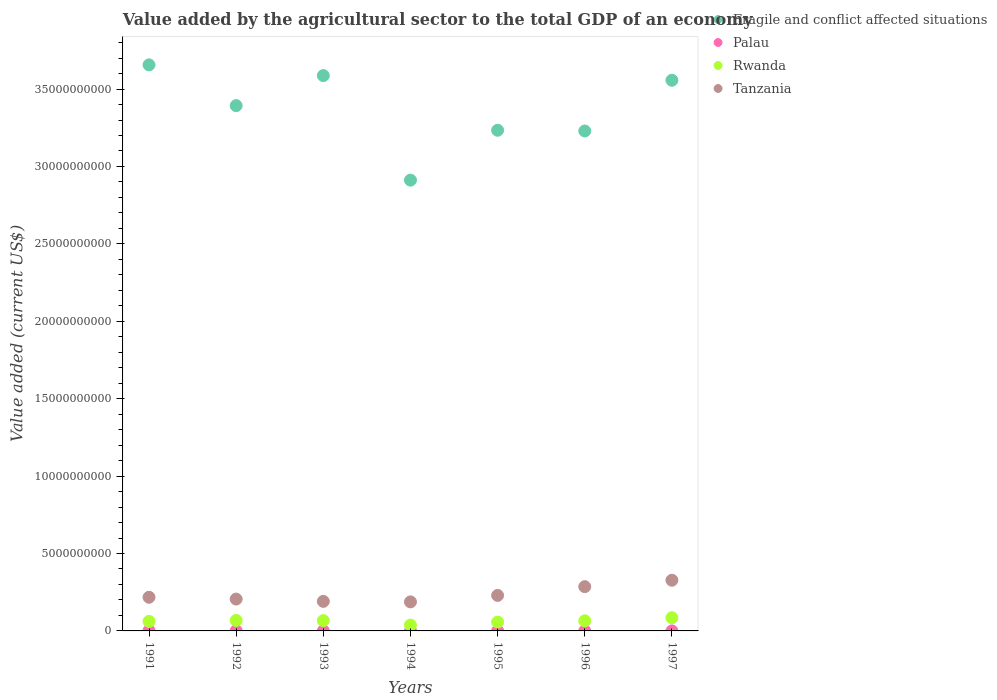How many different coloured dotlines are there?
Your response must be concise. 4. Is the number of dotlines equal to the number of legend labels?
Your response must be concise. Yes. What is the value added by the agricultural sector to the total GDP in Rwanda in 1997?
Provide a short and direct response. 8.51e+08. Across all years, what is the maximum value added by the agricultural sector to the total GDP in Palau?
Keep it short and to the point. 2.36e+07. Across all years, what is the minimum value added by the agricultural sector to the total GDP in Tanzania?
Give a very brief answer. 1.88e+09. In which year was the value added by the agricultural sector to the total GDP in Fragile and conflict affected situations maximum?
Ensure brevity in your answer.  1991. In which year was the value added by the agricultural sector to the total GDP in Rwanda minimum?
Make the answer very short. 1994. What is the total value added by the agricultural sector to the total GDP in Tanzania in the graph?
Provide a short and direct response. 1.64e+1. What is the difference between the value added by the agricultural sector to the total GDP in Rwanda in 1993 and that in 1995?
Give a very brief answer. 9.59e+07. What is the difference between the value added by the agricultural sector to the total GDP in Palau in 1991 and the value added by the agricultural sector to the total GDP in Rwanda in 1995?
Provide a short and direct response. -5.46e+08. What is the average value added by the agricultural sector to the total GDP in Fragile and conflict affected situations per year?
Your answer should be compact. 3.37e+1. In the year 1992, what is the difference between the value added by the agricultural sector to the total GDP in Palau and value added by the agricultural sector to the total GDP in Rwanda?
Your answer should be compact. -6.59e+08. In how many years, is the value added by the agricultural sector to the total GDP in Palau greater than 18000000000 US$?
Your answer should be compact. 0. What is the ratio of the value added by the agricultural sector to the total GDP in Tanzania in 1994 to that in 1997?
Give a very brief answer. 0.57. Is the value added by the agricultural sector to the total GDP in Tanzania in 1991 less than that in 1994?
Give a very brief answer. No. Is the difference between the value added by the agricultural sector to the total GDP in Palau in 1991 and 1997 greater than the difference between the value added by the agricultural sector to the total GDP in Rwanda in 1991 and 1997?
Your answer should be compact. Yes. What is the difference between the highest and the second highest value added by the agricultural sector to the total GDP in Fragile and conflict affected situations?
Ensure brevity in your answer.  6.92e+08. What is the difference between the highest and the lowest value added by the agricultural sector to the total GDP in Palau?
Provide a short and direct response. 2.02e+07. Is the sum of the value added by the agricultural sector to the total GDP in Fragile and conflict affected situations in 1991 and 1995 greater than the maximum value added by the agricultural sector to the total GDP in Palau across all years?
Your answer should be very brief. Yes. Is it the case that in every year, the sum of the value added by the agricultural sector to the total GDP in Fragile and conflict affected situations and value added by the agricultural sector to the total GDP in Tanzania  is greater than the sum of value added by the agricultural sector to the total GDP in Rwanda and value added by the agricultural sector to the total GDP in Palau?
Your answer should be very brief. Yes. How many dotlines are there?
Your answer should be compact. 4. How many years are there in the graph?
Your answer should be very brief. 7. Are the values on the major ticks of Y-axis written in scientific E-notation?
Provide a short and direct response. No. Does the graph contain grids?
Your answer should be compact. No. Where does the legend appear in the graph?
Your answer should be very brief. Top right. How many legend labels are there?
Your response must be concise. 4. What is the title of the graph?
Give a very brief answer. Value added by the agricultural sector to the total GDP of an economy. What is the label or title of the Y-axis?
Your answer should be very brief. Value added (current US$). What is the Value added (current US$) in Fragile and conflict affected situations in 1991?
Your response must be concise. 3.66e+1. What is the Value added (current US$) in Palau in 1991?
Keep it short and to the point. 2.36e+07. What is the Value added (current US$) in Rwanda in 1991?
Your response must be concise. 6.14e+08. What is the Value added (current US$) in Tanzania in 1991?
Ensure brevity in your answer.  2.17e+09. What is the Value added (current US$) in Fragile and conflict affected situations in 1992?
Offer a very short reply. 3.39e+1. What is the Value added (current US$) of Palau in 1992?
Your response must be concise. 1.53e+07. What is the Value added (current US$) in Rwanda in 1992?
Make the answer very short. 6.74e+08. What is the Value added (current US$) in Tanzania in 1992?
Offer a very short reply. 2.06e+09. What is the Value added (current US$) in Fragile and conflict affected situations in 1993?
Ensure brevity in your answer.  3.59e+1. What is the Value added (current US$) of Palau in 1993?
Offer a terse response. 8.08e+06. What is the Value added (current US$) in Rwanda in 1993?
Your response must be concise. 6.65e+08. What is the Value added (current US$) of Tanzania in 1993?
Your response must be concise. 1.91e+09. What is the Value added (current US$) of Fragile and conflict affected situations in 1994?
Provide a short and direct response. 2.91e+1. What is the Value added (current US$) of Palau in 1994?
Make the answer very short. 6.79e+06. What is the Value added (current US$) in Rwanda in 1994?
Give a very brief answer. 3.75e+08. What is the Value added (current US$) of Tanzania in 1994?
Offer a terse response. 1.88e+09. What is the Value added (current US$) of Fragile and conflict affected situations in 1995?
Make the answer very short. 3.23e+1. What is the Value added (current US$) of Palau in 1995?
Keep it short and to the point. 5.50e+06. What is the Value added (current US$) in Rwanda in 1995?
Your answer should be compact. 5.69e+08. What is the Value added (current US$) of Tanzania in 1995?
Offer a terse response. 2.29e+09. What is the Value added (current US$) of Fragile and conflict affected situations in 1996?
Provide a short and direct response. 3.23e+1. What is the Value added (current US$) in Palau in 1996?
Make the answer very short. 4.20e+06. What is the Value added (current US$) of Rwanda in 1996?
Your response must be concise. 6.52e+08. What is the Value added (current US$) of Tanzania in 1996?
Provide a short and direct response. 2.86e+09. What is the Value added (current US$) in Fragile and conflict affected situations in 1997?
Your response must be concise. 3.56e+1. What is the Value added (current US$) of Palau in 1997?
Give a very brief answer. 3.37e+06. What is the Value added (current US$) in Rwanda in 1997?
Offer a terse response. 8.51e+08. What is the Value added (current US$) of Tanzania in 1997?
Provide a short and direct response. 3.27e+09. Across all years, what is the maximum Value added (current US$) in Fragile and conflict affected situations?
Give a very brief answer. 3.66e+1. Across all years, what is the maximum Value added (current US$) of Palau?
Your answer should be compact. 2.36e+07. Across all years, what is the maximum Value added (current US$) in Rwanda?
Give a very brief answer. 8.51e+08. Across all years, what is the maximum Value added (current US$) of Tanzania?
Ensure brevity in your answer.  3.27e+09. Across all years, what is the minimum Value added (current US$) of Fragile and conflict affected situations?
Offer a terse response. 2.91e+1. Across all years, what is the minimum Value added (current US$) in Palau?
Provide a short and direct response. 3.37e+06. Across all years, what is the minimum Value added (current US$) of Rwanda?
Offer a very short reply. 3.75e+08. Across all years, what is the minimum Value added (current US$) of Tanzania?
Ensure brevity in your answer.  1.88e+09. What is the total Value added (current US$) in Fragile and conflict affected situations in the graph?
Your response must be concise. 2.36e+11. What is the total Value added (current US$) in Palau in the graph?
Provide a succinct answer. 6.68e+07. What is the total Value added (current US$) in Rwanda in the graph?
Keep it short and to the point. 4.40e+09. What is the total Value added (current US$) of Tanzania in the graph?
Ensure brevity in your answer.  1.64e+1. What is the difference between the Value added (current US$) of Fragile and conflict affected situations in 1991 and that in 1992?
Provide a succinct answer. 2.63e+09. What is the difference between the Value added (current US$) in Palau in 1991 and that in 1992?
Offer a very short reply. 8.32e+06. What is the difference between the Value added (current US$) of Rwanda in 1991 and that in 1992?
Your response must be concise. -6.02e+07. What is the difference between the Value added (current US$) in Tanzania in 1991 and that in 1992?
Offer a terse response. 1.17e+08. What is the difference between the Value added (current US$) in Fragile and conflict affected situations in 1991 and that in 1993?
Provide a succinct answer. 6.92e+08. What is the difference between the Value added (current US$) of Palau in 1991 and that in 1993?
Provide a short and direct response. 1.55e+07. What is the difference between the Value added (current US$) in Rwanda in 1991 and that in 1993?
Your answer should be compact. -5.08e+07. What is the difference between the Value added (current US$) of Tanzania in 1991 and that in 1993?
Provide a short and direct response. 2.65e+08. What is the difference between the Value added (current US$) of Fragile and conflict affected situations in 1991 and that in 1994?
Make the answer very short. 7.45e+09. What is the difference between the Value added (current US$) in Palau in 1991 and that in 1994?
Make the answer very short. 1.68e+07. What is the difference between the Value added (current US$) in Rwanda in 1991 and that in 1994?
Keep it short and to the point. 2.39e+08. What is the difference between the Value added (current US$) of Tanzania in 1991 and that in 1994?
Ensure brevity in your answer.  2.98e+08. What is the difference between the Value added (current US$) of Fragile and conflict affected situations in 1991 and that in 1995?
Make the answer very short. 4.22e+09. What is the difference between the Value added (current US$) in Palau in 1991 and that in 1995?
Ensure brevity in your answer.  1.81e+07. What is the difference between the Value added (current US$) of Rwanda in 1991 and that in 1995?
Your answer should be very brief. 4.51e+07. What is the difference between the Value added (current US$) in Tanzania in 1991 and that in 1995?
Provide a succinct answer. -1.20e+08. What is the difference between the Value added (current US$) of Fragile and conflict affected situations in 1991 and that in 1996?
Offer a very short reply. 4.27e+09. What is the difference between the Value added (current US$) of Palau in 1991 and that in 1996?
Your answer should be very brief. 1.94e+07. What is the difference between the Value added (current US$) of Rwanda in 1991 and that in 1996?
Provide a succinct answer. -3.81e+07. What is the difference between the Value added (current US$) in Tanzania in 1991 and that in 1996?
Make the answer very short. -6.85e+08. What is the difference between the Value added (current US$) of Fragile and conflict affected situations in 1991 and that in 1997?
Make the answer very short. 9.93e+08. What is the difference between the Value added (current US$) of Palau in 1991 and that in 1997?
Offer a terse response. 2.02e+07. What is the difference between the Value added (current US$) in Rwanda in 1991 and that in 1997?
Your answer should be very brief. -2.37e+08. What is the difference between the Value added (current US$) of Tanzania in 1991 and that in 1997?
Provide a short and direct response. -1.10e+09. What is the difference between the Value added (current US$) in Fragile and conflict affected situations in 1992 and that in 1993?
Make the answer very short. -1.94e+09. What is the difference between the Value added (current US$) in Palau in 1992 and that in 1993?
Provide a short and direct response. 7.19e+06. What is the difference between the Value added (current US$) in Rwanda in 1992 and that in 1993?
Your answer should be compact. 9.31e+06. What is the difference between the Value added (current US$) of Tanzania in 1992 and that in 1993?
Give a very brief answer. 1.49e+08. What is the difference between the Value added (current US$) in Fragile and conflict affected situations in 1992 and that in 1994?
Offer a very short reply. 4.81e+09. What is the difference between the Value added (current US$) of Palau in 1992 and that in 1994?
Keep it short and to the point. 8.48e+06. What is the difference between the Value added (current US$) in Rwanda in 1992 and that in 1994?
Keep it short and to the point. 2.99e+08. What is the difference between the Value added (current US$) of Tanzania in 1992 and that in 1994?
Make the answer very short. 1.81e+08. What is the difference between the Value added (current US$) of Fragile and conflict affected situations in 1992 and that in 1995?
Keep it short and to the point. 1.59e+09. What is the difference between the Value added (current US$) of Palau in 1992 and that in 1995?
Provide a short and direct response. 9.78e+06. What is the difference between the Value added (current US$) of Rwanda in 1992 and that in 1995?
Give a very brief answer. 1.05e+08. What is the difference between the Value added (current US$) in Tanzania in 1992 and that in 1995?
Provide a short and direct response. -2.37e+08. What is the difference between the Value added (current US$) of Fragile and conflict affected situations in 1992 and that in 1996?
Offer a very short reply. 1.64e+09. What is the difference between the Value added (current US$) of Palau in 1992 and that in 1996?
Provide a succinct answer. 1.11e+07. What is the difference between the Value added (current US$) in Rwanda in 1992 and that in 1996?
Ensure brevity in your answer.  2.21e+07. What is the difference between the Value added (current US$) of Tanzania in 1992 and that in 1996?
Provide a short and direct response. -8.02e+08. What is the difference between the Value added (current US$) of Fragile and conflict affected situations in 1992 and that in 1997?
Provide a short and direct response. -1.64e+09. What is the difference between the Value added (current US$) in Palau in 1992 and that in 1997?
Keep it short and to the point. 1.19e+07. What is the difference between the Value added (current US$) in Rwanda in 1992 and that in 1997?
Offer a very short reply. -1.77e+08. What is the difference between the Value added (current US$) in Tanzania in 1992 and that in 1997?
Ensure brevity in your answer.  -1.22e+09. What is the difference between the Value added (current US$) in Fragile and conflict affected situations in 1993 and that in 1994?
Keep it short and to the point. 6.75e+09. What is the difference between the Value added (current US$) of Palau in 1993 and that in 1994?
Your answer should be compact. 1.29e+06. What is the difference between the Value added (current US$) in Rwanda in 1993 and that in 1994?
Give a very brief answer. 2.90e+08. What is the difference between the Value added (current US$) of Tanzania in 1993 and that in 1994?
Provide a succinct answer. 3.27e+07. What is the difference between the Value added (current US$) in Fragile and conflict affected situations in 1993 and that in 1995?
Keep it short and to the point. 3.53e+09. What is the difference between the Value added (current US$) in Palau in 1993 and that in 1995?
Give a very brief answer. 2.58e+06. What is the difference between the Value added (current US$) in Rwanda in 1993 and that in 1995?
Your answer should be very brief. 9.59e+07. What is the difference between the Value added (current US$) in Tanzania in 1993 and that in 1995?
Ensure brevity in your answer.  -3.85e+08. What is the difference between the Value added (current US$) in Fragile and conflict affected situations in 1993 and that in 1996?
Your answer should be very brief. 3.58e+09. What is the difference between the Value added (current US$) in Palau in 1993 and that in 1996?
Make the answer very short. 3.88e+06. What is the difference between the Value added (current US$) in Rwanda in 1993 and that in 1996?
Your response must be concise. 1.28e+07. What is the difference between the Value added (current US$) in Tanzania in 1993 and that in 1996?
Offer a terse response. -9.51e+08. What is the difference between the Value added (current US$) in Fragile and conflict affected situations in 1993 and that in 1997?
Your answer should be very brief. 3.01e+08. What is the difference between the Value added (current US$) in Palau in 1993 and that in 1997?
Keep it short and to the point. 4.71e+06. What is the difference between the Value added (current US$) of Rwanda in 1993 and that in 1997?
Provide a succinct answer. -1.86e+08. What is the difference between the Value added (current US$) of Tanzania in 1993 and that in 1997?
Provide a succinct answer. -1.36e+09. What is the difference between the Value added (current US$) in Fragile and conflict affected situations in 1994 and that in 1995?
Provide a succinct answer. -3.22e+09. What is the difference between the Value added (current US$) in Palau in 1994 and that in 1995?
Offer a very short reply. 1.29e+06. What is the difference between the Value added (current US$) in Rwanda in 1994 and that in 1995?
Your answer should be very brief. -1.94e+08. What is the difference between the Value added (current US$) in Tanzania in 1994 and that in 1995?
Offer a very short reply. -4.18e+08. What is the difference between the Value added (current US$) in Fragile and conflict affected situations in 1994 and that in 1996?
Your answer should be very brief. -3.18e+09. What is the difference between the Value added (current US$) of Palau in 1994 and that in 1996?
Give a very brief answer. 2.59e+06. What is the difference between the Value added (current US$) in Rwanda in 1994 and that in 1996?
Your answer should be very brief. -2.77e+08. What is the difference between the Value added (current US$) of Tanzania in 1994 and that in 1996?
Provide a succinct answer. -9.83e+08. What is the difference between the Value added (current US$) of Fragile and conflict affected situations in 1994 and that in 1997?
Provide a short and direct response. -6.45e+09. What is the difference between the Value added (current US$) in Palau in 1994 and that in 1997?
Your response must be concise. 3.42e+06. What is the difference between the Value added (current US$) in Rwanda in 1994 and that in 1997?
Give a very brief answer. -4.76e+08. What is the difference between the Value added (current US$) of Tanzania in 1994 and that in 1997?
Offer a terse response. -1.40e+09. What is the difference between the Value added (current US$) in Fragile and conflict affected situations in 1995 and that in 1996?
Offer a very short reply. 4.73e+07. What is the difference between the Value added (current US$) of Palau in 1995 and that in 1996?
Ensure brevity in your answer.  1.29e+06. What is the difference between the Value added (current US$) in Rwanda in 1995 and that in 1996?
Make the answer very short. -8.32e+07. What is the difference between the Value added (current US$) of Tanzania in 1995 and that in 1996?
Your answer should be compact. -5.65e+08. What is the difference between the Value added (current US$) of Fragile and conflict affected situations in 1995 and that in 1997?
Provide a succinct answer. -3.23e+09. What is the difference between the Value added (current US$) of Palau in 1995 and that in 1997?
Provide a short and direct response. 2.13e+06. What is the difference between the Value added (current US$) in Rwanda in 1995 and that in 1997?
Give a very brief answer. -2.82e+08. What is the difference between the Value added (current US$) of Tanzania in 1995 and that in 1997?
Provide a succinct answer. -9.80e+08. What is the difference between the Value added (current US$) in Fragile and conflict affected situations in 1996 and that in 1997?
Provide a succinct answer. -3.28e+09. What is the difference between the Value added (current US$) in Palau in 1996 and that in 1997?
Keep it short and to the point. 8.35e+05. What is the difference between the Value added (current US$) of Rwanda in 1996 and that in 1997?
Offer a terse response. -1.99e+08. What is the difference between the Value added (current US$) in Tanzania in 1996 and that in 1997?
Keep it short and to the point. -4.14e+08. What is the difference between the Value added (current US$) in Fragile and conflict affected situations in 1991 and the Value added (current US$) in Palau in 1992?
Offer a terse response. 3.65e+1. What is the difference between the Value added (current US$) in Fragile and conflict affected situations in 1991 and the Value added (current US$) in Rwanda in 1992?
Provide a short and direct response. 3.59e+1. What is the difference between the Value added (current US$) of Fragile and conflict affected situations in 1991 and the Value added (current US$) of Tanzania in 1992?
Provide a succinct answer. 3.45e+1. What is the difference between the Value added (current US$) in Palau in 1991 and the Value added (current US$) in Rwanda in 1992?
Make the answer very short. -6.51e+08. What is the difference between the Value added (current US$) in Palau in 1991 and the Value added (current US$) in Tanzania in 1992?
Offer a very short reply. -2.03e+09. What is the difference between the Value added (current US$) in Rwanda in 1991 and the Value added (current US$) in Tanzania in 1992?
Offer a very short reply. -1.44e+09. What is the difference between the Value added (current US$) in Fragile and conflict affected situations in 1991 and the Value added (current US$) in Palau in 1993?
Ensure brevity in your answer.  3.66e+1. What is the difference between the Value added (current US$) of Fragile and conflict affected situations in 1991 and the Value added (current US$) of Rwanda in 1993?
Offer a very short reply. 3.59e+1. What is the difference between the Value added (current US$) of Fragile and conflict affected situations in 1991 and the Value added (current US$) of Tanzania in 1993?
Your answer should be compact. 3.47e+1. What is the difference between the Value added (current US$) in Palau in 1991 and the Value added (current US$) in Rwanda in 1993?
Your answer should be very brief. -6.42e+08. What is the difference between the Value added (current US$) of Palau in 1991 and the Value added (current US$) of Tanzania in 1993?
Provide a succinct answer. -1.88e+09. What is the difference between the Value added (current US$) in Rwanda in 1991 and the Value added (current US$) in Tanzania in 1993?
Make the answer very short. -1.29e+09. What is the difference between the Value added (current US$) in Fragile and conflict affected situations in 1991 and the Value added (current US$) in Palau in 1994?
Offer a very short reply. 3.66e+1. What is the difference between the Value added (current US$) of Fragile and conflict affected situations in 1991 and the Value added (current US$) of Rwanda in 1994?
Give a very brief answer. 3.62e+1. What is the difference between the Value added (current US$) of Fragile and conflict affected situations in 1991 and the Value added (current US$) of Tanzania in 1994?
Provide a short and direct response. 3.47e+1. What is the difference between the Value added (current US$) in Palau in 1991 and the Value added (current US$) in Rwanda in 1994?
Give a very brief answer. -3.51e+08. What is the difference between the Value added (current US$) in Palau in 1991 and the Value added (current US$) in Tanzania in 1994?
Give a very brief answer. -1.85e+09. What is the difference between the Value added (current US$) of Rwanda in 1991 and the Value added (current US$) of Tanzania in 1994?
Offer a terse response. -1.26e+09. What is the difference between the Value added (current US$) of Fragile and conflict affected situations in 1991 and the Value added (current US$) of Palau in 1995?
Your response must be concise. 3.66e+1. What is the difference between the Value added (current US$) in Fragile and conflict affected situations in 1991 and the Value added (current US$) in Rwanda in 1995?
Provide a succinct answer. 3.60e+1. What is the difference between the Value added (current US$) of Fragile and conflict affected situations in 1991 and the Value added (current US$) of Tanzania in 1995?
Keep it short and to the point. 3.43e+1. What is the difference between the Value added (current US$) in Palau in 1991 and the Value added (current US$) in Rwanda in 1995?
Ensure brevity in your answer.  -5.46e+08. What is the difference between the Value added (current US$) of Palau in 1991 and the Value added (current US$) of Tanzania in 1995?
Your answer should be very brief. -2.27e+09. What is the difference between the Value added (current US$) of Rwanda in 1991 and the Value added (current US$) of Tanzania in 1995?
Provide a short and direct response. -1.68e+09. What is the difference between the Value added (current US$) of Fragile and conflict affected situations in 1991 and the Value added (current US$) of Palau in 1996?
Your answer should be very brief. 3.66e+1. What is the difference between the Value added (current US$) in Fragile and conflict affected situations in 1991 and the Value added (current US$) in Rwanda in 1996?
Your answer should be very brief. 3.59e+1. What is the difference between the Value added (current US$) in Fragile and conflict affected situations in 1991 and the Value added (current US$) in Tanzania in 1996?
Offer a terse response. 3.37e+1. What is the difference between the Value added (current US$) of Palau in 1991 and the Value added (current US$) of Rwanda in 1996?
Offer a terse response. -6.29e+08. What is the difference between the Value added (current US$) in Palau in 1991 and the Value added (current US$) in Tanzania in 1996?
Ensure brevity in your answer.  -2.84e+09. What is the difference between the Value added (current US$) of Rwanda in 1991 and the Value added (current US$) of Tanzania in 1996?
Give a very brief answer. -2.24e+09. What is the difference between the Value added (current US$) of Fragile and conflict affected situations in 1991 and the Value added (current US$) of Palau in 1997?
Keep it short and to the point. 3.66e+1. What is the difference between the Value added (current US$) in Fragile and conflict affected situations in 1991 and the Value added (current US$) in Rwanda in 1997?
Make the answer very short. 3.57e+1. What is the difference between the Value added (current US$) of Fragile and conflict affected situations in 1991 and the Value added (current US$) of Tanzania in 1997?
Provide a succinct answer. 3.33e+1. What is the difference between the Value added (current US$) of Palau in 1991 and the Value added (current US$) of Rwanda in 1997?
Offer a terse response. -8.27e+08. What is the difference between the Value added (current US$) of Palau in 1991 and the Value added (current US$) of Tanzania in 1997?
Offer a terse response. -3.25e+09. What is the difference between the Value added (current US$) in Rwanda in 1991 and the Value added (current US$) in Tanzania in 1997?
Your answer should be very brief. -2.66e+09. What is the difference between the Value added (current US$) of Fragile and conflict affected situations in 1992 and the Value added (current US$) of Palau in 1993?
Give a very brief answer. 3.39e+1. What is the difference between the Value added (current US$) in Fragile and conflict affected situations in 1992 and the Value added (current US$) in Rwanda in 1993?
Offer a terse response. 3.33e+1. What is the difference between the Value added (current US$) of Fragile and conflict affected situations in 1992 and the Value added (current US$) of Tanzania in 1993?
Your answer should be very brief. 3.20e+1. What is the difference between the Value added (current US$) in Palau in 1992 and the Value added (current US$) in Rwanda in 1993?
Give a very brief answer. -6.50e+08. What is the difference between the Value added (current US$) of Palau in 1992 and the Value added (current US$) of Tanzania in 1993?
Your answer should be compact. -1.89e+09. What is the difference between the Value added (current US$) of Rwanda in 1992 and the Value added (current US$) of Tanzania in 1993?
Your answer should be very brief. -1.23e+09. What is the difference between the Value added (current US$) in Fragile and conflict affected situations in 1992 and the Value added (current US$) in Palau in 1994?
Offer a very short reply. 3.39e+1. What is the difference between the Value added (current US$) of Fragile and conflict affected situations in 1992 and the Value added (current US$) of Rwanda in 1994?
Your answer should be compact. 3.36e+1. What is the difference between the Value added (current US$) in Fragile and conflict affected situations in 1992 and the Value added (current US$) in Tanzania in 1994?
Your answer should be compact. 3.21e+1. What is the difference between the Value added (current US$) in Palau in 1992 and the Value added (current US$) in Rwanda in 1994?
Your answer should be compact. -3.60e+08. What is the difference between the Value added (current US$) in Palau in 1992 and the Value added (current US$) in Tanzania in 1994?
Your response must be concise. -1.86e+09. What is the difference between the Value added (current US$) of Rwanda in 1992 and the Value added (current US$) of Tanzania in 1994?
Your answer should be compact. -1.20e+09. What is the difference between the Value added (current US$) of Fragile and conflict affected situations in 1992 and the Value added (current US$) of Palau in 1995?
Your response must be concise. 3.39e+1. What is the difference between the Value added (current US$) of Fragile and conflict affected situations in 1992 and the Value added (current US$) of Rwanda in 1995?
Your response must be concise. 3.34e+1. What is the difference between the Value added (current US$) in Fragile and conflict affected situations in 1992 and the Value added (current US$) in Tanzania in 1995?
Provide a short and direct response. 3.16e+1. What is the difference between the Value added (current US$) of Palau in 1992 and the Value added (current US$) of Rwanda in 1995?
Your answer should be very brief. -5.54e+08. What is the difference between the Value added (current US$) of Palau in 1992 and the Value added (current US$) of Tanzania in 1995?
Your response must be concise. -2.28e+09. What is the difference between the Value added (current US$) of Rwanda in 1992 and the Value added (current US$) of Tanzania in 1995?
Ensure brevity in your answer.  -1.62e+09. What is the difference between the Value added (current US$) of Fragile and conflict affected situations in 1992 and the Value added (current US$) of Palau in 1996?
Offer a very short reply. 3.39e+1. What is the difference between the Value added (current US$) in Fragile and conflict affected situations in 1992 and the Value added (current US$) in Rwanda in 1996?
Keep it short and to the point. 3.33e+1. What is the difference between the Value added (current US$) of Fragile and conflict affected situations in 1992 and the Value added (current US$) of Tanzania in 1996?
Give a very brief answer. 3.11e+1. What is the difference between the Value added (current US$) of Palau in 1992 and the Value added (current US$) of Rwanda in 1996?
Your answer should be compact. -6.37e+08. What is the difference between the Value added (current US$) of Palau in 1992 and the Value added (current US$) of Tanzania in 1996?
Offer a terse response. -2.84e+09. What is the difference between the Value added (current US$) of Rwanda in 1992 and the Value added (current US$) of Tanzania in 1996?
Your response must be concise. -2.18e+09. What is the difference between the Value added (current US$) of Fragile and conflict affected situations in 1992 and the Value added (current US$) of Palau in 1997?
Your response must be concise. 3.39e+1. What is the difference between the Value added (current US$) in Fragile and conflict affected situations in 1992 and the Value added (current US$) in Rwanda in 1997?
Make the answer very short. 3.31e+1. What is the difference between the Value added (current US$) of Fragile and conflict affected situations in 1992 and the Value added (current US$) of Tanzania in 1997?
Your response must be concise. 3.07e+1. What is the difference between the Value added (current US$) of Palau in 1992 and the Value added (current US$) of Rwanda in 1997?
Offer a very short reply. -8.36e+08. What is the difference between the Value added (current US$) in Palau in 1992 and the Value added (current US$) in Tanzania in 1997?
Your response must be concise. -3.26e+09. What is the difference between the Value added (current US$) of Rwanda in 1992 and the Value added (current US$) of Tanzania in 1997?
Offer a terse response. -2.60e+09. What is the difference between the Value added (current US$) in Fragile and conflict affected situations in 1993 and the Value added (current US$) in Palau in 1994?
Make the answer very short. 3.59e+1. What is the difference between the Value added (current US$) in Fragile and conflict affected situations in 1993 and the Value added (current US$) in Rwanda in 1994?
Provide a succinct answer. 3.55e+1. What is the difference between the Value added (current US$) in Fragile and conflict affected situations in 1993 and the Value added (current US$) in Tanzania in 1994?
Your response must be concise. 3.40e+1. What is the difference between the Value added (current US$) in Palau in 1993 and the Value added (current US$) in Rwanda in 1994?
Offer a very short reply. -3.67e+08. What is the difference between the Value added (current US$) of Palau in 1993 and the Value added (current US$) of Tanzania in 1994?
Provide a succinct answer. -1.87e+09. What is the difference between the Value added (current US$) in Rwanda in 1993 and the Value added (current US$) in Tanzania in 1994?
Keep it short and to the point. -1.21e+09. What is the difference between the Value added (current US$) of Fragile and conflict affected situations in 1993 and the Value added (current US$) of Palau in 1995?
Your answer should be very brief. 3.59e+1. What is the difference between the Value added (current US$) of Fragile and conflict affected situations in 1993 and the Value added (current US$) of Rwanda in 1995?
Your response must be concise. 3.53e+1. What is the difference between the Value added (current US$) of Fragile and conflict affected situations in 1993 and the Value added (current US$) of Tanzania in 1995?
Your answer should be very brief. 3.36e+1. What is the difference between the Value added (current US$) in Palau in 1993 and the Value added (current US$) in Rwanda in 1995?
Give a very brief answer. -5.61e+08. What is the difference between the Value added (current US$) of Palau in 1993 and the Value added (current US$) of Tanzania in 1995?
Provide a short and direct response. -2.29e+09. What is the difference between the Value added (current US$) in Rwanda in 1993 and the Value added (current US$) in Tanzania in 1995?
Offer a very short reply. -1.63e+09. What is the difference between the Value added (current US$) in Fragile and conflict affected situations in 1993 and the Value added (current US$) in Palau in 1996?
Keep it short and to the point. 3.59e+1. What is the difference between the Value added (current US$) of Fragile and conflict affected situations in 1993 and the Value added (current US$) of Rwanda in 1996?
Give a very brief answer. 3.52e+1. What is the difference between the Value added (current US$) of Fragile and conflict affected situations in 1993 and the Value added (current US$) of Tanzania in 1996?
Provide a short and direct response. 3.30e+1. What is the difference between the Value added (current US$) in Palau in 1993 and the Value added (current US$) in Rwanda in 1996?
Your answer should be very brief. -6.44e+08. What is the difference between the Value added (current US$) in Palau in 1993 and the Value added (current US$) in Tanzania in 1996?
Your answer should be very brief. -2.85e+09. What is the difference between the Value added (current US$) of Rwanda in 1993 and the Value added (current US$) of Tanzania in 1996?
Your answer should be very brief. -2.19e+09. What is the difference between the Value added (current US$) of Fragile and conflict affected situations in 1993 and the Value added (current US$) of Palau in 1997?
Keep it short and to the point. 3.59e+1. What is the difference between the Value added (current US$) of Fragile and conflict affected situations in 1993 and the Value added (current US$) of Rwanda in 1997?
Make the answer very short. 3.50e+1. What is the difference between the Value added (current US$) in Fragile and conflict affected situations in 1993 and the Value added (current US$) in Tanzania in 1997?
Give a very brief answer. 3.26e+1. What is the difference between the Value added (current US$) in Palau in 1993 and the Value added (current US$) in Rwanda in 1997?
Provide a short and direct response. -8.43e+08. What is the difference between the Value added (current US$) of Palau in 1993 and the Value added (current US$) of Tanzania in 1997?
Keep it short and to the point. -3.27e+09. What is the difference between the Value added (current US$) of Rwanda in 1993 and the Value added (current US$) of Tanzania in 1997?
Offer a terse response. -2.61e+09. What is the difference between the Value added (current US$) of Fragile and conflict affected situations in 1994 and the Value added (current US$) of Palau in 1995?
Offer a terse response. 2.91e+1. What is the difference between the Value added (current US$) of Fragile and conflict affected situations in 1994 and the Value added (current US$) of Rwanda in 1995?
Give a very brief answer. 2.85e+1. What is the difference between the Value added (current US$) of Fragile and conflict affected situations in 1994 and the Value added (current US$) of Tanzania in 1995?
Ensure brevity in your answer.  2.68e+1. What is the difference between the Value added (current US$) of Palau in 1994 and the Value added (current US$) of Rwanda in 1995?
Ensure brevity in your answer.  -5.62e+08. What is the difference between the Value added (current US$) in Palau in 1994 and the Value added (current US$) in Tanzania in 1995?
Offer a very short reply. -2.29e+09. What is the difference between the Value added (current US$) in Rwanda in 1994 and the Value added (current US$) in Tanzania in 1995?
Your response must be concise. -1.92e+09. What is the difference between the Value added (current US$) of Fragile and conflict affected situations in 1994 and the Value added (current US$) of Palau in 1996?
Offer a terse response. 2.91e+1. What is the difference between the Value added (current US$) in Fragile and conflict affected situations in 1994 and the Value added (current US$) in Rwanda in 1996?
Make the answer very short. 2.85e+1. What is the difference between the Value added (current US$) in Fragile and conflict affected situations in 1994 and the Value added (current US$) in Tanzania in 1996?
Your response must be concise. 2.63e+1. What is the difference between the Value added (current US$) of Palau in 1994 and the Value added (current US$) of Rwanda in 1996?
Give a very brief answer. -6.46e+08. What is the difference between the Value added (current US$) of Palau in 1994 and the Value added (current US$) of Tanzania in 1996?
Make the answer very short. -2.85e+09. What is the difference between the Value added (current US$) of Rwanda in 1994 and the Value added (current US$) of Tanzania in 1996?
Offer a terse response. -2.48e+09. What is the difference between the Value added (current US$) in Fragile and conflict affected situations in 1994 and the Value added (current US$) in Palau in 1997?
Offer a terse response. 2.91e+1. What is the difference between the Value added (current US$) of Fragile and conflict affected situations in 1994 and the Value added (current US$) of Rwanda in 1997?
Provide a short and direct response. 2.83e+1. What is the difference between the Value added (current US$) of Fragile and conflict affected situations in 1994 and the Value added (current US$) of Tanzania in 1997?
Your answer should be compact. 2.58e+1. What is the difference between the Value added (current US$) in Palau in 1994 and the Value added (current US$) in Rwanda in 1997?
Keep it short and to the point. -8.44e+08. What is the difference between the Value added (current US$) in Palau in 1994 and the Value added (current US$) in Tanzania in 1997?
Keep it short and to the point. -3.27e+09. What is the difference between the Value added (current US$) of Rwanda in 1994 and the Value added (current US$) of Tanzania in 1997?
Your response must be concise. -2.90e+09. What is the difference between the Value added (current US$) in Fragile and conflict affected situations in 1995 and the Value added (current US$) in Palau in 1996?
Ensure brevity in your answer.  3.23e+1. What is the difference between the Value added (current US$) of Fragile and conflict affected situations in 1995 and the Value added (current US$) of Rwanda in 1996?
Offer a very short reply. 3.17e+1. What is the difference between the Value added (current US$) of Fragile and conflict affected situations in 1995 and the Value added (current US$) of Tanzania in 1996?
Give a very brief answer. 2.95e+1. What is the difference between the Value added (current US$) of Palau in 1995 and the Value added (current US$) of Rwanda in 1996?
Offer a very short reply. -6.47e+08. What is the difference between the Value added (current US$) in Palau in 1995 and the Value added (current US$) in Tanzania in 1996?
Make the answer very short. -2.85e+09. What is the difference between the Value added (current US$) in Rwanda in 1995 and the Value added (current US$) in Tanzania in 1996?
Provide a succinct answer. -2.29e+09. What is the difference between the Value added (current US$) in Fragile and conflict affected situations in 1995 and the Value added (current US$) in Palau in 1997?
Your answer should be compact. 3.23e+1. What is the difference between the Value added (current US$) of Fragile and conflict affected situations in 1995 and the Value added (current US$) of Rwanda in 1997?
Offer a very short reply. 3.15e+1. What is the difference between the Value added (current US$) in Fragile and conflict affected situations in 1995 and the Value added (current US$) in Tanzania in 1997?
Your answer should be very brief. 2.91e+1. What is the difference between the Value added (current US$) of Palau in 1995 and the Value added (current US$) of Rwanda in 1997?
Give a very brief answer. -8.45e+08. What is the difference between the Value added (current US$) in Palau in 1995 and the Value added (current US$) in Tanzania in 1997?
Your answer should be very brief. -3.27e+09. What is the difference between the Value added (current US$) in Rwanda in 1995 and the Value added (current US$) in Tanzania in 1997?
Provide a succinct answer. -2.70e+09. What is the difference between the Value added (current US$) in Fragile and conflict affected situations in 1996 and the Value added (current US$) in Palau in 1997?
Ensure brevity in your answer.  3.23e+1. What is the difference between the Value added (current US$) of Fragile and conflict affected situations in 1996 and the Value added (current US$) of Rwanda in 1997?
Give a very brief answer. 3.14e+1. What is the difference between the Value added (current US$) in Fragile and conflict affected situations in 1996 and the Value added (current US$) in Tanzania in 1997?
Ensure brevity in your answer.  2.90e+1. What is the difference between the Value added (current US$) of Palau in 1996 and the Value added (current US$) of Rwanda in 1997?
Ensure brevity in your answer.  -8.47e+08. What is the difference between the Value added (current US$) in Palau in 1996 and the Value added (current US$) in Tanzania in 1997?
Give a very brief answer. -3.27e+09. What is the difference between the Value added (current US$) in Rwanda in 1996 and the Value added (current US$) in Tanzania in 1997?
Give a very brief answer. -2.62e+09. What is the average Value added (current US$) of Fragile and conflict affected situations per year?
Make the answer very short. 3.37e+1. What is the average Value added (current US$) of Palau per year?
Give a very brief answer. 9.54e+06. What is the average Value added (current US$) of Rwanda per year?
Ensure brevity in your answer.  6.29e+08. What is the average Value added (current US$) in Tanzania per year?
Provide a short and direct response. 2.35e+09. In the year 1991, what is the difference between the Value added (current US$) of Fragile and conflict affected situations and Value added (current US$) of Palau?
Keep it short and to the point. 3.65e+1. In the year 1991, what is the difference between the Value added (current US$) of Fragile and conflict affected situations and Value added (current US$) of Rwanda?
Make the answer very short. 3.59e+1. In the year 1991, what is the difference between the Value added (current US$) of Fragile and conflict affected situations and Value added (current US$) of Tanzania?
Ensure brevity in your answer.  3.44e+1. In the year 1991, what is the difference between the Value added (current US$) in Palau and Value added (current US$) in Rwanda?
Make the answer very short. -5.91e+08. In the year 1991, what is the difference between the Value added (current US$) in Palau and Value added (current US$) in Tanzania?
Keep it short and to the point. -2.15e+09. In the year 1991, what is the difference between the Value added (current US$) in Rwanda and Value added (current US$) in Tanzania?
Offer a terse response. -1.56e+09. In the year 1992, what is the difference between the Value added (current US$) of Fragile and conflict affected situations and Value added (current US$) of Palau?
Give a very brief answer. 3.39e+1. In the year 1992, what is the difference between the Value added (current US$) in Fragile and conflict affected situations and Value added (current US$) in Rwanda?
Your response must be concise. 3.33e+1. In the year 1992, what is the difference between the Value added (current US$) of Fragile and conflict affected situations and Value added (current US$) of Tanzania?
Make the answer very short. 3.19e+1. In the year 1992, what is the difference between the Value added (current US$) of Palau and Value added (current US$) of Rwanda?
Your response must be concise. -6.59e+08. In the year 1992, what is the difference between the Value added (current US$) in Palau and Value added (current US$) in Tanzania?
Your answer should be compact. -2.04e+09. In the year 1992, what is the difference between the Value added (current US$) in Rwanda and Value added (current US$) in Tanzania?
Keep it short and to the point. -1.38e+09. In the year 1993, what is the difference between the Value added (current US$) of Fragile and conflict affected situations and Value added (current US$) of Palau?
Your answer should be compact. 3.59e+1. In the year 1993, what is the difference between the Value added (current US$) of Fragile and conflict affected situations and Value added (current US$) of Rwanda?
Give a very brief answer. 3.52e+1. In the year 1993, what is the difference between the Value added (current US$) of Fragile and conflict affected situations and Value added (current US$) of Tanzania?
Offer a terse response. 3.40e+1. In the year 1993, what is the difference between the Value added (current US$) in Palau and Value added (current US$) in Rwanda?
Provide a succinct answer. -6.57e+08. In the year 1993, what is the difference between the Value added (current US$) in Palau and Value added (current US$) in Tanzania?
Your response must be concise. -1.90e+09. In the year 1993, what is the difference between the Value added (current US$) of Rwanda and Value added (current US$) of Tanzania?
Your response must be concise. -1.24e+09. In the year 1994, what is the difference between the Value added (current US$) of Fragile and conflict affected situations and Value added (current US$) of Palau?
Offer a very short reply. 2.91e+1. In the year 1994, what is the difference between the Value added (current US$) in Fragile and conflict affected situations and Value added (current US$) in Rwanda?
Your answer should be compact. 2.87e+1. In the year 1994, what is the difference between the Value added (current US$) of Fragile and conflict affected situations and Value added (current US$) of Tanzania?
Your response must be concise. 2.72e+1. In the year 1994, what is the difference between the Value added (current US$) in Palau and Value added (current US$) in Rwanda?
Keep it short and to the point. -3.68e+08. In the year 1994, what is the difference between the Value added (current US$) of Palau and Value added (current US$) of Tanzania?
Offer a terse response. -1.87e+09. In the year 1994, what is the difference between the Value added (current US$) in Rwanda and Value added (current US$) in Tanzania?
Your answer should be very brief. -1.50e+09. In the year 1995, what is the difference between the Value added (current US$) in Fragile and conflict affected situations and Value added (current US$) in Palau?
Your answer should be compact. 3.23e+1. In the year 1995, what is the difference between the Value added (current US$) in Fragile and conflict affected situations and Value added (current US$) in Rwanda?
Your answer should be compact. 3.18e+1. In the year 1995, what is the difference between the Value added (current US$) of Fragile and conflict affected situations and Value added (current US$) of Tanzania?
Give a very brief answer. 3.00e+1. In the year 1995, what is the difference between the Value added (current US$) in Palau and Value added (current US$) in Rwanda?
Offer a terse response. -5.64e+08. In the year 1995, what is the difference between the Value added (current US$) in Palau and Value added (current US$) in Tanzania?
Ensure brevity in your answer.  -2.29e+09. In the year 1995, what is the difference between the Value added (current US$) in Rwanda and Value added (current US$) in Tanzania?
Make the answer very short. -1.72e+09. In the year 1996, what is the difference between the Value added (current US$) in Fragile and conflict affected situations and Value added (current US$) in Palau?
Offer a terse response. 3.23e+1. In the year 1996, what is the difference between the Value added (current US$) of Fragile and conflict affected situations and Value added (current US$) of Rwanda?
Provide a succinct answer. 3.16e+1. In the year 1996, what is the difference between the Value added (current US$) in Fragile and conflict affected situations and Value added (current US$) in Tanzania?
Ensure brevity in your answer.  2.94e+1. In the year 1996, what is the difference between the Value added (current US$) of Palau and Value added (current US$) of Rwanda?
Provide a succinct answer. -6.48e+08. In the year 1996, what is the difference between the Value added (current US$) of Palau and Value added (current US$) of Tanzania?
Your answer should be very brief. -2.86e+09. In the year 1996, what is the difference between the Value added (current US$) in Rwanda and Value added (current US$) in Tanzania?
Provide a succinct answer. -2.21e+09. In the year 1997, what is the difference between the Value added (current US$) of Fragile and conflict affected situations and Value added (current US$) of Palau?
Provide a succinct answer. 3.56e+1. In the year 1997, what is the difference between the Value added (current US$) of Fragile and conflict affected situations and Value added (current US$) of Rwanda?
Ensure brevity in your answer.  3.47e+1. In the year 1997, what is the difference between the Value added (current US$) in Fragile and conflict affected situations and Value added (current US$) in Tanzania?
Give a very brief answer. 3.23e+1. In the year 1997, what is the difference between the Value added (current US$) in Palau and Value added (current US$) in Rwanda?
Offer a very short reply. -8.48e+08. In the year 1997, what is the difference between the Value added (current US$) of Palau and Value added (current US$) of Tanzania?
Offer a very short reply. -3.27e+09. In the year 1997, what is the difference between the Value added (current US$) in Rwanda and Value added (current US$) in Tanzania?
Offer a very short reply. -2.42e+09. What is the ratio of the Value added (current US$) of Fragile and conflict affected situations in 1991 to that in 1992?
Make the answer very short. 1.08. What is the ratio of the Value added (current US$) of Palau in 1991 to that in 1992?
Give a very brief answer. 1.54. What is the ratio of the Value added (current US$) of Rwanda in 1991 to that in 1992?
Your response must be concise. 0.91. What is the ratio of the Value added (current US$) of Tanzania in 1991 to that in 1992?
Your response must be concise. 1.06. What is the ratio of the Value added (current US$) of Fragile and conflict affected situations in 1991 to that in 1993?
Your answer should be compact. 1.02. What is the ratio of the Value added (current US$) in Palau in 1991 to that in 1993?
Provide a succinct answer. 2.92. What is the ratio of the Value added (current US$) of Rwanda in 1991 to that in 1993?
Your response must be concise. 0.92. What is the ratio of the Value added (current US$) of Tanzania in 1991 to that in 1993?
Offer a very short reply. 1.14. What is the ratio of the Value added (current US$) in Fragile and conflict affected situations in 1991 to that in 1994?
Provide a short and direct response. 1.26. What is the ratio of the Value added (current US$) of Palau in 1991 to that in 1994?
Give a very brief answer. 3.47. What is the ratio of the Value added (current US$) of Rwanda in 1991 to that in 1994?
Keep it short and to the point. 1.64. What is the ratio of the Value added (current US$) in Tanzania in 1991 to that in 1994?
Your answer should be very brief. 1.16. What is the ratio of the Value added (current US$) of Fragile and conflict affected situations in 1991 to that in 1995?
Your answer should be very brief. 1.13. What is the ratio of the Value added (current US$) in Palau in 1991 to that in 1995?
Your answer should be compact. 4.29. What is the ratio of the Value added (current US$) in Rwanda in 1991 to that in 1995?
Give a very brief answer. 1.08. What is the ratio of the Value added (current US$) of Tanzania in 1991 to that in 1995?
Provide a short and direct response. 0.95. What is the ratio of the Value added (current US$) in Fragile and conflict affected situations in 1991 to that in 1996?
Provide a succinct answer. 1.13. What is the ratio of the Value added (current US$) of Palau in 1991 to that in 1996?
Your answer should be compact. 5.61. What is the ratio of the Value added (current US$) in Rwanda in 1991 to that in 1996?
Give a very brief answer. 0.94. What is the ratio of the Value added (current US$) in Tanzania in 1991 to that in 1996?
Keep it short and to the point. 0.76. What is the ratio of the Value added (current US$) of Fragile and conflict affected situations in 1991 to that in 1997?
Keep it short and to the point. 1.03. What is the ratio of the Value added (current US$) in Palau in 1991 to that in 1997?
Your response must be concise. 7. What is the ratio of the Value added (current US$) of Rwanda in 1991 to that in 1997?
Ensure brevity in your answer.  0.72. What is the ratio of the Value added (current US$) in Tanzania in 1991 to that in 1997?
Your answer should be compact. 0.66. What is the ratio of the Value added (current US$) of Fragile and conflict affected situations in 1992 to that in 1993?
Give a very brief answer. 0.95. What is the ratio of the Value added (current US$) of Palau in 1992 to that in 1993?
Provide a short and direct response. 1.89. What is the ratio of the Value added (current US$) in Rwanda in 1992 to that in 1993?
Ensure brevity in your answer.  1.01. What is the ratio of the Value added (current US$) of Tanzania in 1992 to that in 1993?
Your response must be concise. 1.08. What is the ratio of the Value added (current US$) of Fragile and conflict affected situations in 1992 to that in 1994?
Give a very brief answer. 1.17. What is the ratio of the Value added (current US$) of Palau in 1992 to that in 1994?
Your answer should be compact. 2.25. What is the ratio of the Value added (current US$) of Rwanda in 1992 to that in 1994?
Offer a very short reply. 1.8. What is the ratio of the Value added (current US$) in Tanzania in 1992 to that in 1994?
Ensure brevity in your answer.  1.1. What is the ratio of the Value added (current US$) of Fragile and conflict affected situations in 1992 to that in 1995?
Your response must be concise. 1.05. What is the ratio of the Value added (current US$) in Palau in 1992 to that in 1995?
Your answer should be compact. 2.78. What is the ratio of the Value added (current US$) of Rwanda in 1992 to that in 1995?
Ensure brevity in your answer.  1.18. What is the ratio of the Value added (current US$) of Tanzania in 1992 to that in 1995?
Make the answer very short. 0.9. What is the ratio of the Value added (current US$) in Fragile and conflict affected situations in 1992 to that in 1996?
Your answer should be compact. 1.05. What is the ratio of the Value added (current US$) in Palau in 1992 to that in 1996?
Offer a very short reply. 3.63. What is the ratio of the Value added (current US$) in Rwanda in 1992 to that in 1996?
Give a very brief answer. 1.03. What is the ratio of the Value added (current US$) in Tanzania in 1992 to that in 1996?
Keep it short and to the point. 0.72. What is the ratio of the Value added (current US$) in Fragile and conflict affected situations in 1992 to that in 1997?
Give a very brief answer. 0.95. What is the ratio of the Value added (current US$) of Palau in 1992 to that in 1997?
Provide a succinct answer. 4.53. What is the ratio of the Value added (current US$) of Rwanda in 1992 to that in 1997?
Offer a very short reply. 0.79. What is the ratio of the Value added (current US$) in Tanzania in 1992 to that in 1997?
Your response must be concise. 0.63. What is the ratio of the Value added (current US$) in Fragile and conflict affected situations in 1993 to that in 1994?
Offer a terse response. 1.23. What is the ratio of the Value added (current US$) in Palau in 1993 to that in 1994?
Your response must be concise. 1.19. What is the ratio of the Value added (current US$) of Rwanda in 1993 to that in 1994?
Your answer should be compact. 1.77. What is the ratio of the Value added (current US$) of Tanzania in 1993 to that in 1994?
Your response must be concise. 1.02. What is the ratio of the Value added (current US$) of Fragile and conflict affected situations in 1993 to that in 1995?
Make the answer very short. 1.11. What is the ratio of the Value added (current US$) in Palau in 1993 to that in 1995?
Your response must be concise. 1.47. What is the ratio of the Value added (current US$) of Rwanda in 1993 to that in 1995?
Give a very brief answer. 1.17. What is the ratio of the Value added (current US$) of Tanzania in 1993 to that in 1995?
Keep it short and to the point. 0.83. What is the ratio of the Value added (current US$) in Fragile and conflict affected situations in 1993 to that in 1996?
Offer a very short reply. 1.11. What is the ratio of the Value added (current US$) of Palau in 1993 to that in 1996?
Ensure brevity in your answer.  1.92. What is the ratio of the Value added (current US$) of Rwanda in 1993 to that in 1996?
Ensure brevity in your answer.  1.02. What is the ratio of the Value added (current US$) in Tanzania in 1993 to that in 1996?
Provide a succinct answer. 0.67. What is the ratio of the Value added (current US$) of Fragile and conflict affected situations in 1993 to that in 1997?
Ensure brevity in your answer.  1.01. What is the ratio of the Value added (current US$) in Palau in 1993 to that in 1997?
Provide a short and direct response. 2.4. What is the ratio of the Value added (current US$) of Rwanda in 1993 to that in 1997?
Ensure brevity in your answer.  0.78. What is the ratio of the Value added (current US$) of Tanzania in 1993 to that in 1997?
Ensure brevity in your answer.  0.58. What is the ratio of the Value added (current US$) of Fragile and conflict affected situations in 1994 to that in 1995?
Offer a terse response. 0.9. What is the ratio of the Value added (current US$) of Palau in 1994 to that in 1995?
Your answer should be compact. 1.24. What is the ratio of the Value added (current US$) of Rwanda in 1994 to that in 1995?
Your response must be concise. 0.66. What is the ratio of the Value added (current US$) in Tanzania in 1994 to that in 1995?
Your answer should be compact. 0.82. What is the ratio of the Value added (current US$) in Fragile and conflict affected situations in 1994 to that in 1996?
Your response must be concise. 0.9. What is the ratio of the Value added (current US$) of Palau in 1994 to that in 1996?
Provide a succinct answer. 1.62. What is the ratio of the Value added (current US$) of Rwanda in 1994 to that in 1996?
Give a very brief answer. 0.57. What is the ratio of the Value added (current US$) in Tanzania in 1994 to that in 1996?
Your response must be concise. 0.66. What is the ratio of the Value added (current US$) of Fragile and conflict affected situations in 1994 to that in 1997?
Your answer should be very brief. 0.82. What is the ratio of the Value added (current US$) in Palau in 1994 to that in 1997?
Your answer should be compact. 2.02. What is the ratio of the Value added (current US$) of Rwanda in 1994 to that in 1997?
Your answer should be compact. 0.44. What is the ratio of the Value added (current US$) of Tanzania in 1994 to that in 1997?
Provide a short and direct response. 0.57. What is the ratio of the Value added (current US$) in Palau in 1995 to that in 1996?
Your response must be concise. 1.31. What is the ratio of the Value added (current US$) in Rwanda in 1995 to that in 1996?
Offer a very short reply. 0.87. What is the ratio of the Value added (current US$) in Tanzania in 1995 to that in 1996?
Your response must be concise. 0.8. What is the ratio of the Value added (current US$) in Fragile and conflict affected situations in 1995 to that in 1997?
Provide a short and direct response. 0.91. What is the ratio of the Value added (current US$) in Palau in 1995 to that in 1997?
Provide a succinct answer. 1.63. What is the ratio of the Value added (current US$) of Rwanda in 1995 to that in 1997?
Provide a short and direct response. 0.67. What is the ratio of the Value added (current US$) in Tanzania in 1995 to that in 1997?
Provide a succinct answer. 0.7. What is the ratio of the Value added (current US$) in Fragile and conflict affected situations in 1996 to that in 1997?
Provide a succinct answer. 0.91. What is the ratio of the Value added (current US$) of Palau in 1996 to that in 1997?
Give a very brief answer. 1.25. What is the ratio of the Value added (current US$) of Rwanda in 1996 to that in 1997?
Your answer should be very brief. 0.77. What is the ratio of the Value added (current US$) of Tanzania in 1996 to that in 1997?
Offer a terse response. 0.87. What is the difference between the highest and the second highest Value added (current US$) in Fragile and conflict affected situations?
Your answer should be very brief. 6.92e+08. What is the difference between the highest and the second highest Value added (current US$) of Palau?
Your answer should be compact. 8.32e+06. What is the difference between the highest and the second highest Value added (current US$) of Rwanda?
Your answer should be compact. 1.77e+08. What is the difference between the highest and the second highest Value added (current US$) in Tanzania?
Provide a short and direct response. 4.14e+08. What is the difference between the highest and the lowest Value added (current US$) in Fragile and conflict affected situations?
Provide a succinct answer. 7.45e+09. What is the difference between the highest and the lowest Value added (current US$) in Palau?
Offer a very short reply. 2.02e+07. What is the difference between the highest and the lowest Value added (current US$) of Rwanda?
Your answer should be compact. 4.76e+08. What is the difference between the highest and the lowest Value added (current US$) in Tanzania?
Your response must be concise. 1.40e+09. 